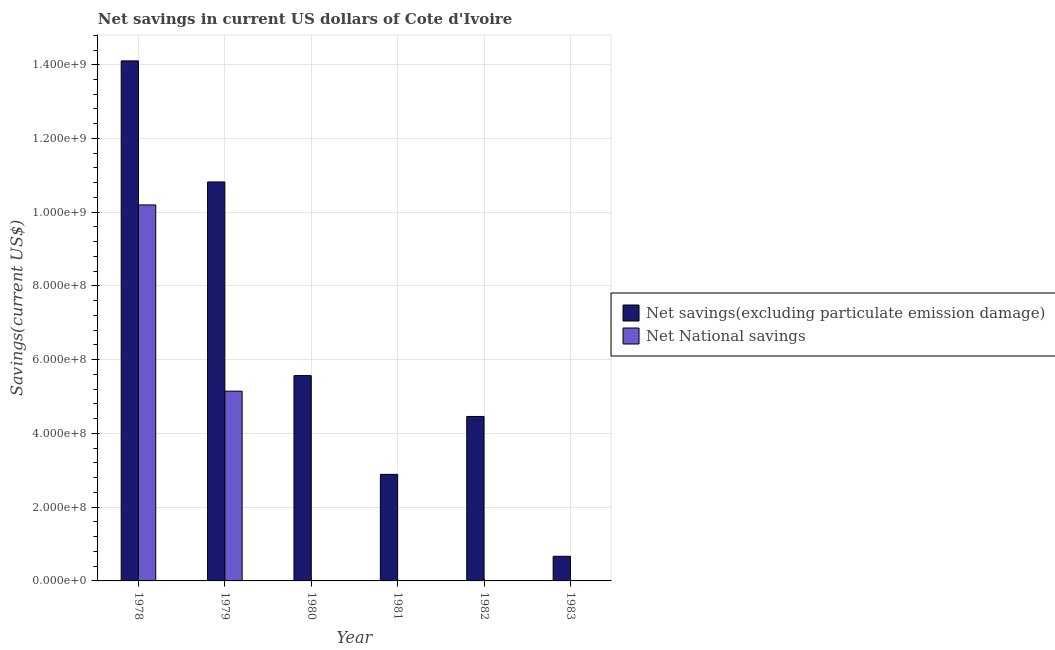How many bars are there on the 2nd tick from the left?
Your answer should be compact. 2. What is the label of the 5th group of bars from the left?
Your answer should be very brief. 1982. Across all years, what is the maximum net national savings?
Offer a very short reply. 1.02e+09. In which year was the net savings(excluding particulate emission damage) maximum?
Provide a short and direct response. 1978. What is the total net savings(excluding particulate emission damage) in the graph?
Your response must be concise. 3.85e+09. What is the difference between the net savings(excluding particulate emission damage) in 1979 and that in 1982?
Your response must be concise. 6.36e+08. What is the difference between the net savings(excluding particulate emission damage) in 1982 and the net national savings in 1983?
Provide a short and direct response. 3.79e+08. What is the average net savings(excluding particulate emission damage) per year?
Offer a very short reply. 6.42e+08. In the year 1981, what is the difference between the net savings(excluding particulate emission damage) and net national savings?
Offer a very short reply. 0. In how many years, is the net national savings greater than 800000000 US$?
Provide a succinct answer. 1. What is the ratio of the net savings(excluding particulate emission damage) in 1979 to that in 1981?
Your answer should be compact. 3.74. Is the net savings(excluding particulate emission damage) in 1979 less than that in 1981?
Keep it short and to the point. No. Is the difference between the net savings(excluding particulate emission damage) in 1978 and 1979 greater than the difference between the net national savings in 1978 and 1979?
Your response must be concise. No. What is the difference between the highest and the second highest net national savings?
Offer a very short reply. 5.05e+08. What is the difference between the highest and the lowest net savings(excluding particulate emission damage)?
Make the answer very short. 1.34e+09. In how many years, is the net savings(excluding particulate emission damage) greater than the average net savings(excluding particulate emission damage) taken over all years?
Keep it short and to the point. 2. How many bars are there?
Your response must be concise. 9. Are all the bars in the graph horizontal?
Your answer should be very brief. No. How many years are there in the graph?
Make the answer very short. 6. What is the difference between two consecutive major ticks on the Y-axis?
Keep it short and to the point. 2.00e+08. Does the graph contain grids?
Your response must be concise. Yes. How many legend labels are there?
Provide a succinct answer. 2. What is the title of the graph?
Provide a short and direct response. Net savings in current US dollars of Cote d'Ivoire. Does "Lower secondary rate" appear as one of the legend labels in the graph?
Your response must be concise. No. What is the label or title of the Y-axis?
Make the answer very short. Savings(current US$). What is the Savings(current US$) of Net savings(excluding particulate emission damage) in 1978?
Make the answer very short. 1.41e+09. What is the Savings(current US$) of Net National savings in 1978?
Provide a succinct answer. 1.02e+09. What is the Savings(current US$) in Net savings(excluding particulate emission damage) in 1979?
Provide a succinct answer. 1.08e+09. What is the Savings(current US$) of Net National savings in 1979?
Your answer should be very brief. 5.15e+08. What is the Savings(current US$) of Net savings(excluding particulate emission damage) in 1980?
Provide a short and direct response. 5.57e+08. What is the Savings(current US$) of Net National savings in 1980?
Your answer should be compact. 1.86e+04. What is the Savings(current US$) of Net savings(excluding particulate emission damage) in 1981?
Keep it short and to the point. 2.89e+08. What is the Savings(current US$) in Net savings(excluding particulate emission damage) in 1982?
Keep it short and to the point. 4.46e+08. What is the Savings(current US$) of Net National savings in 1982?
Provide a short and direct response. 0. What is the Savings(current US$) in Net savings(excluding particulate emission damage) in 1983?
Keep it short and to the point. 6.67e+07. Across all years, what is the maximum Savings(current US$) of Net savings(excluding particulate emission damage)?
Your answer should be compact. 1.41e+09. Across all years, what is the maximum Savings(current US$) in Net National savings?
Ensure brevity in your answer.  1.02e+09. Across all years, what is the minimum Savings(current US$) in Net savings(excluding particulate emission damage)?
Ensure brevity in your answer.  6.67e+07. Across all years, what is the minimum Savings(current US$) of Net National savings?
Your answer should be compact. 0. What is the total Savings(current US$) of Net savings(excluding particulate emission damage) in the graph?
Your response must be concise. 3.85e+09. What is the total Savings(current US$) of Net National savings in the graph?
Keep it short and to the point. 1.53e+09. What is the difference between the Savings(current US$) in Net savings(excluding particulate emission damage) in 1978 and that in 1979?
Make the answer very short. 3.28e+08. What is the difference between the Savings(current US$) in Net National savings in 1978 and that in 1979?
Keep it short and to the point. 5.05e+08. What is the difference between the Savings(current US$) in Net savings(excluding particulate emission damage) in 1978 and that in 1980?
Offer a very short reply. 8.54e+08. What is the difference between the Savings(current US$) of Net National savings in 1978 and that in 1980?
Keep it short and to the point. 1.02e+09. What is the difference between the Savings(current US$) of Net savings(excluding particulate emission damage) in 1978 and that in 1981?
Provide a short and direct response. 1.12e+09. What is the difference between the Savings(current US$) in Net savings(excluding particulate emission damage) in 1978 and that in 1982?
Keep it short and to the point. 9.64e+08. What is the difference between the Savings(current US$) of Net savings(excluding particulate emission damage) in 1978 and that in 1983?
Make the answer very short. 1.34e+09. What is the difference between the Savings(current US$) in Net savings(excluding particulate emission damage) in 1979 and that in 1980?
Offer a terse response. 5.25e+08. What is the difference between the Savings(current US$) of Net National savings in 1979 and that in 1980?
Offer a very short reply. 5.15e+08. What is the difference between the Savings(current US$) of Net savings(excluding particulate emission damage) in 1979 and that in 1981?
Give a very brief answer. 7.93e+08. What is the difference between the Savings(current US$) of Net savings(excluding particulate emission damage) in 1979 and that in 1982?
Your answer should be compact. 6.36e+08. What is the difference between the Savings(current US$) in Net savings(excluding particulate emission damage) in 1979 and that in 1983?
Keep it short and to the point. 1.02e+09. What is the difference between the Savings(current US$) in Net savings(excluding particulate emission damage) in 1980 and that in 1981?
Offer a very short reply. 2.68e+08. What is the difference between the Savings(current US$) in Net savings(excluding particulate emission damage) in 1980 and that in 1982?
Give a very brief answer. 1.11e+08. What is the difference between the Savings(current US$) of Net savings(excluding particulate emission damage) in 1980 and that in 1983?
Give a very brief answer. 4.90e+08. What is the difference between the Savings(current US$) in Net savings(excluding particulate emission damage) in 1981 and that in 1982?
Provide a succinct answer. -1.57e+08. What is the difference between the Savings(current US$) of Net savings(excluding particulate emission damage) in 1981 and that in 1983?
Your answer should be very brief. 2.22e+08. What is the difference between the Savings(current US$) in Net savings(excluding particulate emission damage) in 1982 and that in 1983?
Keep it short and to the point. 3.79e+08. What is the difference between the Savings(current US$) in Net savings(excluding particulate emission damage) in 1978 and the Savings(current US$) in Net National savings in 1979?
Offer a terse response. 8.96e+08. What is the difference between the Savings(current US$) of Net savings(excluding particulate emission damage) in 1978 and the Savings(current US$) of Net National savings in 1980?
Keep it short and to the point. 1.41e+09. What is the difference between the Savings(current US$) of Net savings(excluding particulate emission damage) in 1979 and the Savings(current US$) of Net National savings in 1980?
Provide a short and direct response. 1.08e+09. What is the average Savings(current US$) in Net savings(excluding particulate emission damage) per year?
Your answer should be very brief. 6.42e+08. What is the average Savings(current US$) of Net National savings per year?
Provide a succinct answer. 2.56e+08. In the year 1978, what is the difference between the Savings(current US$) in Net savings(excluding particulate emission damage) and Savings(current US$) in Net National savings?
Provide a short and direct response. 3.91e+08. In the year 1979, what is the difference between the Savings(current US$) of Net savings(excluding particulate emission damage) and Savings(current US$) of Net National savings?
Your answer should be very brief. 5.67e+08. In the year 1980, what is the difference between the Savings(current US$) of Net savings(excluding particulate emission damage) and Savings(current US$) of Net National savings?
Give a very brief answer. 5.57e+08. What is the ratio of the Savings(current US$) of Net savings(excluding particulate emission damage) in 1978 to that in 1979?
Your answer should be very brief. 1.3. What is the ratio of the Savings(current US$) of Net National savings in 1978 to that in 1979?
Give a very brief answer. 1.98. What is the ratio of the Savings(current US$) of Net savings(excluding particulate emission damage) in 1978 to that in 1980?
Offer a terse response. 2.53. What is the ratio of the Savings(current US$) in Net National savings in 1978 to that in 1980?
Offer a very short reply. 5.48e+04. What is the ratio of the Savings(current US$) of Net savings(excluding particulate emission damage) in 1978 to that in 1981?
Provide a short and direct response. 4.88. What is the ratio of the Savings(current US$) of Net savings(excluding particulate emission damage) in 1978 to that in 1982?
Offer a terse response. 3.16. What is the ratio of the Savings(current US$) in Net savings(excluding particulate emission damage) in 1978 to that in 1983?
Give a very brief answer. 21.13. What is the ratio of the Savings(current US$) in Net savings(excluding particulate emission damage) in 1979 to that in 1980?
Ensure brevity in your answer.  1.94. What is the ratio of the Savings(current US$) of Net National savings in 1979 to that in 1980?
Your answer should be very brief. 2.77e+04. What is the ratio of the Savings(current US$) of Net savings(excluding particulate emission damage) in 1979 to that in 1981?
Give a very brief answer. 3.74. What is the ratio of the Savings(current US$) in Net savings(excluding particulate emission damage) in 1979 to that in 1982?
Give a very brief answer. 2.43. What is the ratio of the Savings(current US$) of Net savings(excluding particulate emission damage) in 1979 to that in 1983?
Offer a very short reply. 16.21. What is the ratio of the Savings(current US$) of Net savings(excluding particulate emission damage) in 1980 to that in 1981?
Give a very brief answer. 1.93. What is the ratio of the Savings(current US$) in Net savings(excluding particulate emission damage) in 1980 to that in 1982?
Give a very brief answer. 1.25. What is the ratio of the Savings(current US$) in Net savings(excluding particulate emission damage) in 1980 to that in 1983?
Provide a short and direct response. 8.34. What is the ratio of the Savings(current US$) in Net savings(excluding particulate emission damage) in 1981 to that in 1982?
Ensure brevity in your answer.  0.65. What is the ratio of the Savings(current US$) in Net savings(excluding particulate emission damage) in 1981 to that in 1983?
Ensure brevity in your answer.  4.33. What is the ratio of the Savings(current US$) of Net savings(excluding particulate emission damage) in 1982 to that in 1983?
Your answer should be very brief. 6.68. What is the difference between the highest and the second highest Savings(current US$) of Net savings(excluding particulate emission damage)?
Give a very brief answer. 3.28e+08. What is the difference between the highest and the second highest Savings(current US$) of Net National savings?
Give a very brief answer. 5.05e+08. What is the difference between the highest and the lowest Savings(current US$) of Net savings(excluding particulate emission damage)?
Your answer should be compact. 1.34e+09. What is the difference between the highest and the lowest Savings(current US$) in Net National savings?
Your answer should be very brief. 1.02e+09. 